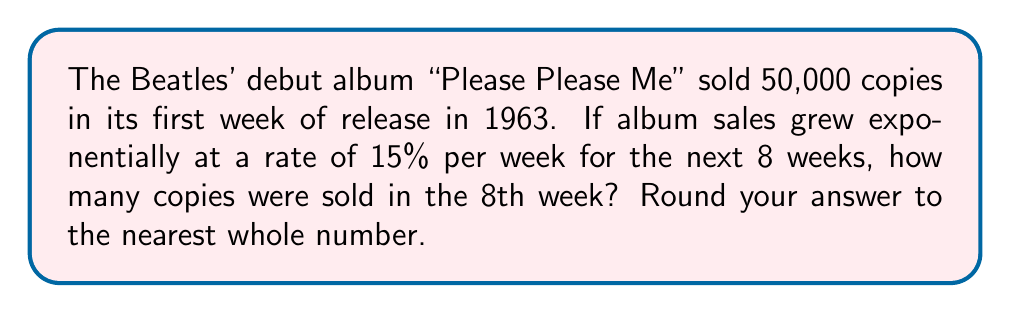Can you answer this question? Let's approach this step-by-step using the exponential growth formula:

1) The exponential growth formula is:
   $A = P(1 + r)^t$
   Where:
   $A$ = Final amount
   $P$ = Initial amount
   $r$ = Growth rate (as a decimal)
   $t$ = Time periods

2) We have:
   $P = 50,000$ (initial sales)
   $r = 0.15$ (15% growth rate)
   $t = 7$ (we want the 8th week, which is 7 weeks after the initial week)

3) Plugging these values into our formula:
   $A = 50,000(1 + 0.15)^7$

4) Simplify:
   $A = 50,000(1.15)^7$

5) Calculate:
   $A = 50,000 * 2.6600$
   $A = 133,000.22$

6) Rounding to the nearest whole number:
   $A ≈ 133,000$

Thus, in the 8th week, approximately 133,000 copies were sold.
Answer: 133,000 copies 